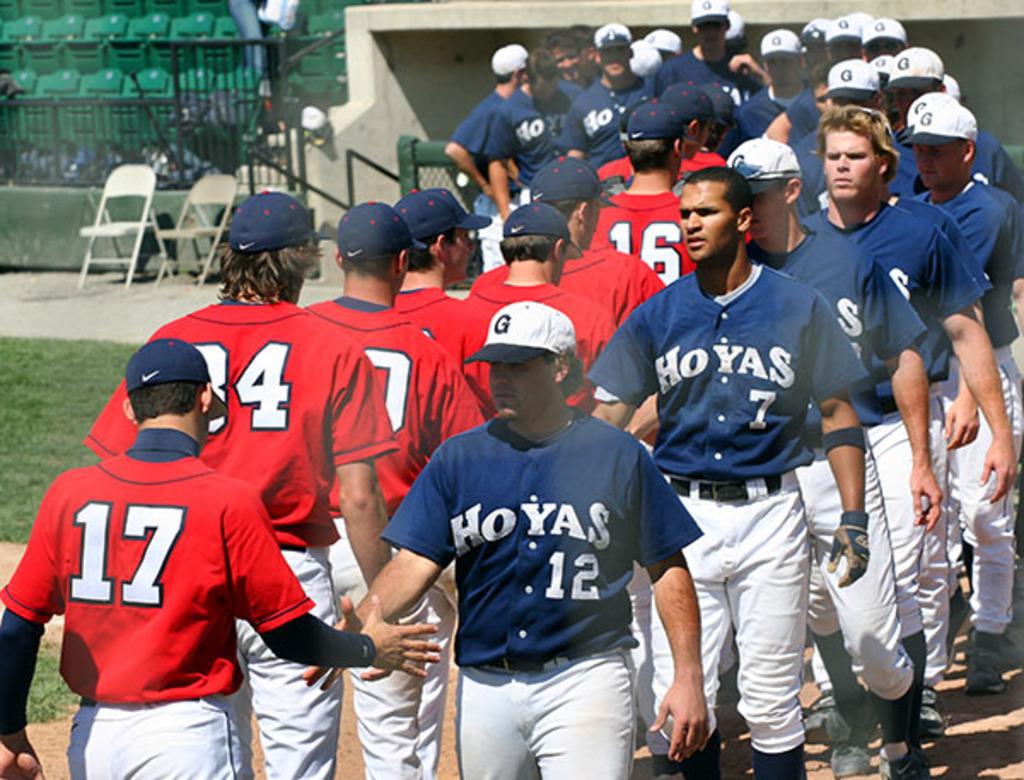What is the number of the player who is 2nd in line?
Your response must be concise. 7. 